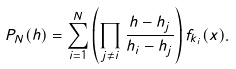<formula> <loc_0><loc_0><loc_500><loc_500>P _ { N } ( h ) = \sum _ { i = 1 } ^ { N } \left ( \prod _ { j \neq i } \frac { h - h _ { j } } { h _ { i } - h _ { j } } \right ) f _ { k _ { i } } ( x ) .</formula> 